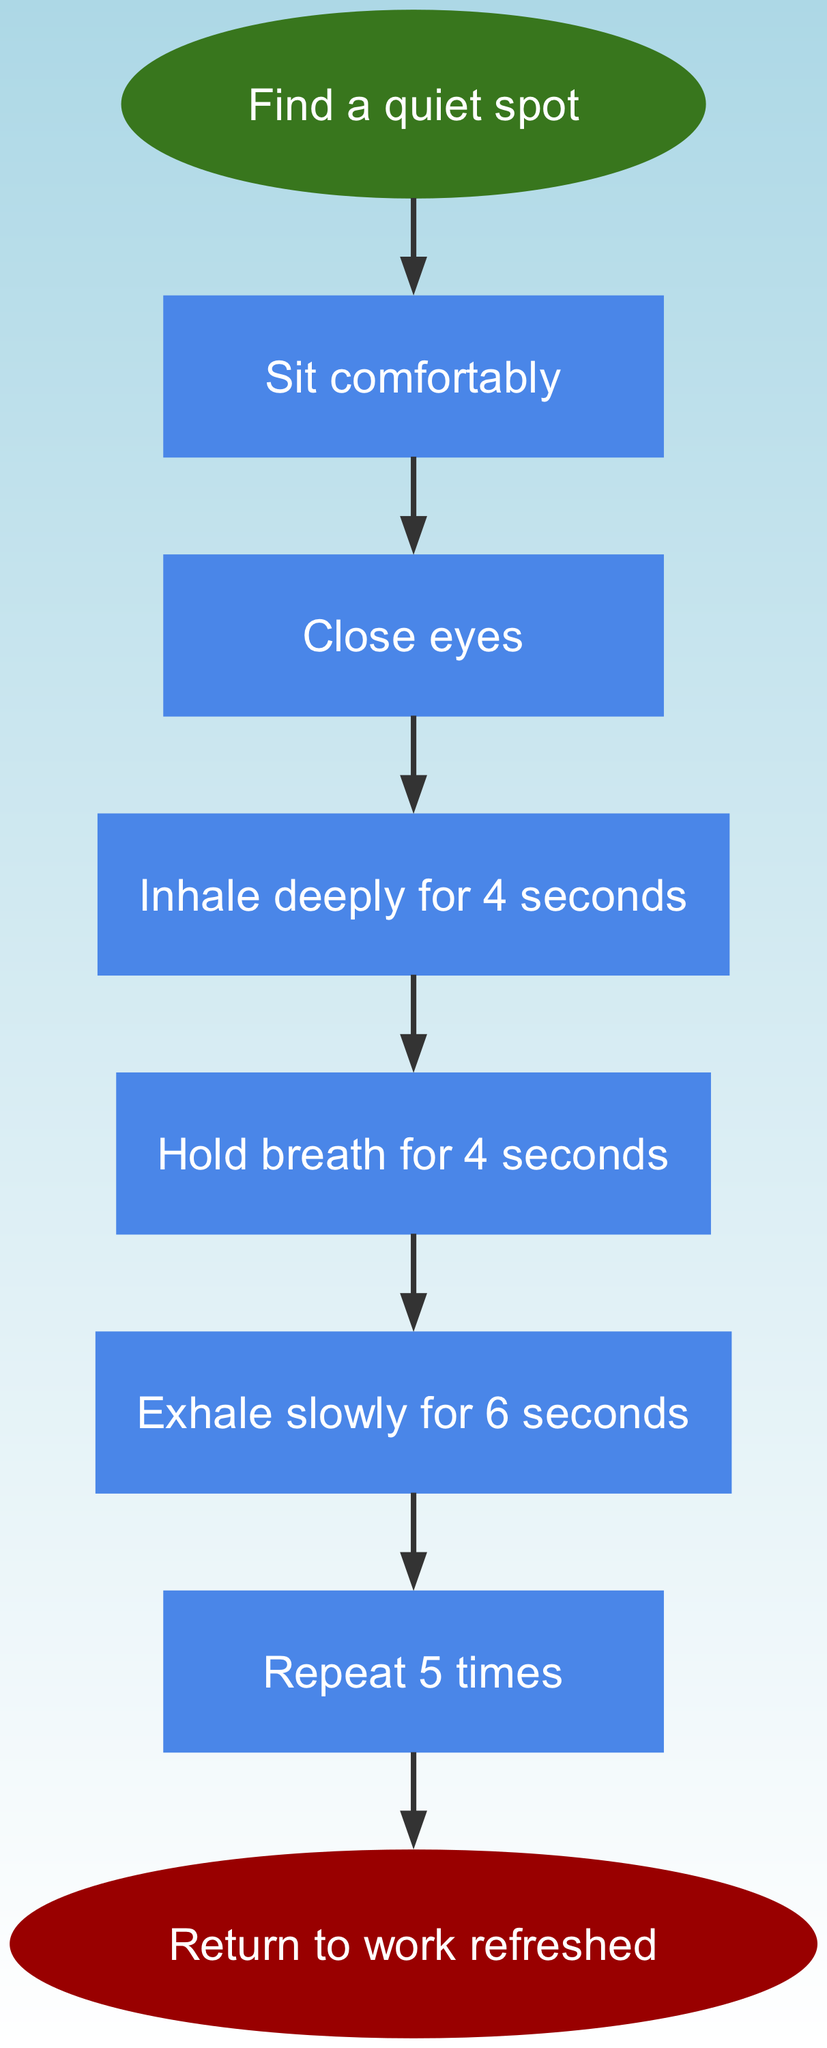What is the first step in the breathing exercise? The first step listed in the flow chart is "Find a quiet spot", which is the initial action to take before starting the exercise.
Answer: Find a quiet spot How many steps are there in the breathing exercise? By counting the nodes from "Find a quiet spot" to "Return to work refreshed", we find a total of 7 steps, including the start and end nodes.
Answer: 7 What do you need to do after sitting comfortably? According to the flow chart, the step immediately following "Sit comfortably" is "Close eyes", which is the next action in the sequence.
Answer: Close eyes How long do you hold your breath? The diagram specifies that you need to hold your breath for 4 seconds, as indicated in the step labeled "Hold breath for 4 seconds".
Answer: 4 seconds What should you do after exhaling? The flow chart indicates that after exhaling slowly for 6 seconds, the next step is "Repeat 5 times", meaning you should repeat the breathing process.
Answer: Repeat 5 times What is the final outcome of this breathing exercise? At the end of the flow chart, it states that the final outcome is to "Return to work refreshed", summarizing the goal of the exercise.
Answer: Return to work refreshed What is the total duration of one complete breathing cycle (inhale, hold, and exhale)? By analyzing the times given in the steps, the inhalation lasts for 4 seconds, holding takes another 4 seconds, and exhalation lasts 6 seconds. Adding these together gives us a total of 14 seconds for one cycle.
Answer: 14 seconds What type of activity should be done before starting the breathing exercise? Before starting the exercise, the flow chart indicates that you should find a quiet spot, which is a preparatory action to help create a conducive environment.
Answer: Find a quiet spot What shape is the 'end' node in the diagram? The end node, labeled "Return to work refreshed", is shaped as an ellipse as per the style defined for that node type in the flow chart.
Answer: Ellipse 